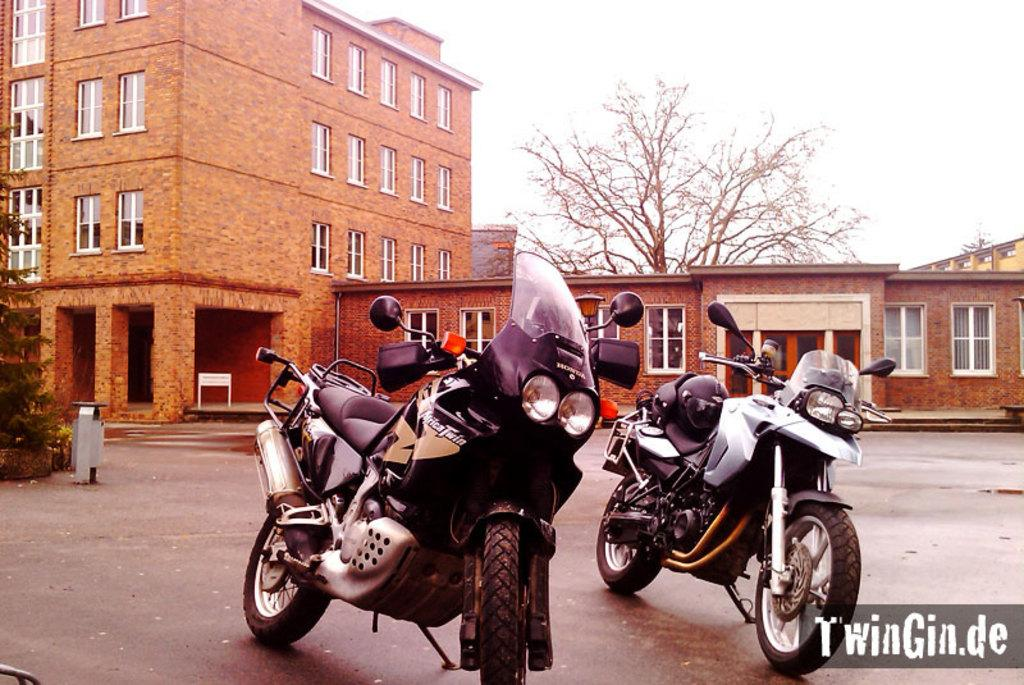What vehicles are parked on the road in the image? There are two motorbikes parked on the road in the image. What type of structure can be seen in the image? There is a building with windows in the image. What natural elements are present in the image? There are trees in the image. What man-made object can be seen in the image? There is a signboard in the image. What is the condition of the sky in the image? The sky is visible in the image and appears cloudy. How many pizzas are being delivered by the motorbikes in the image? There is no mention of pizzas or delivery in the image; it only shows two parked motorbikes. What type of beef is being sold at the building in the image? There is no indication of any beef or sale in the image; it only shows a building with windows. 